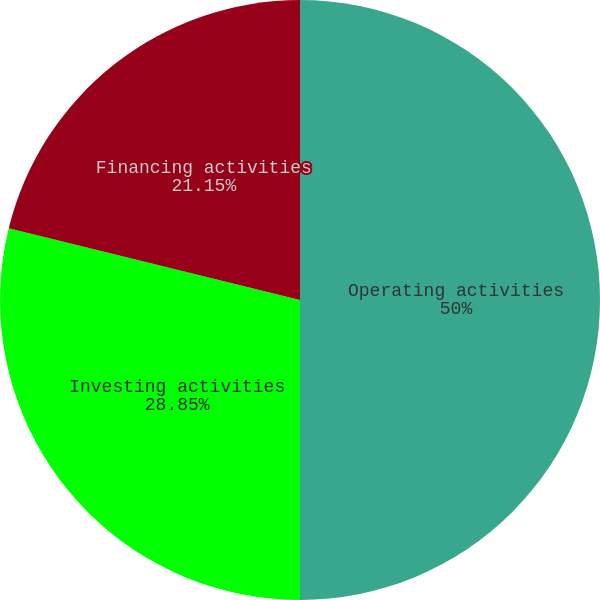Convert chart. <chart><loc_0><loc_0><loc_500><loc_500><pie_chart><fcel>Operating activities<fcel>Investing activities<fcel>Financing activities<nl><fcel>50.0%<fcel>28.85%<fcel>21.15%<nl></chart> 